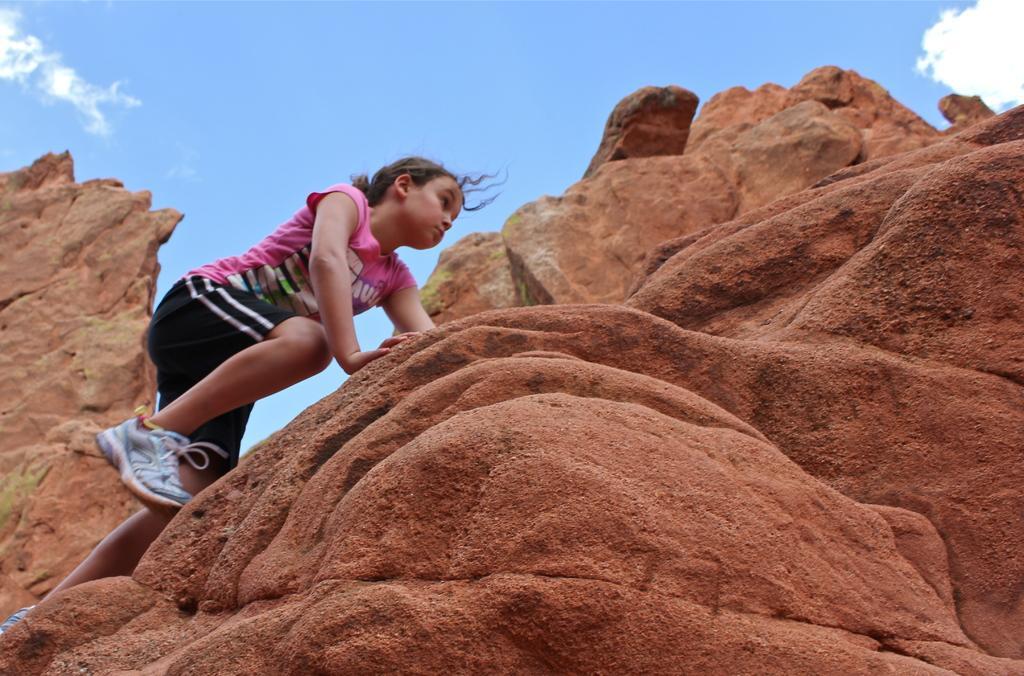In one or two sentences, can you explain what this image depicts? In the image there are brown color rocks. On the rocks there is a girl with pink t-shirt, black short and with white shoes is climbing the rocks. At the top of the image there is a sky with clouds. 